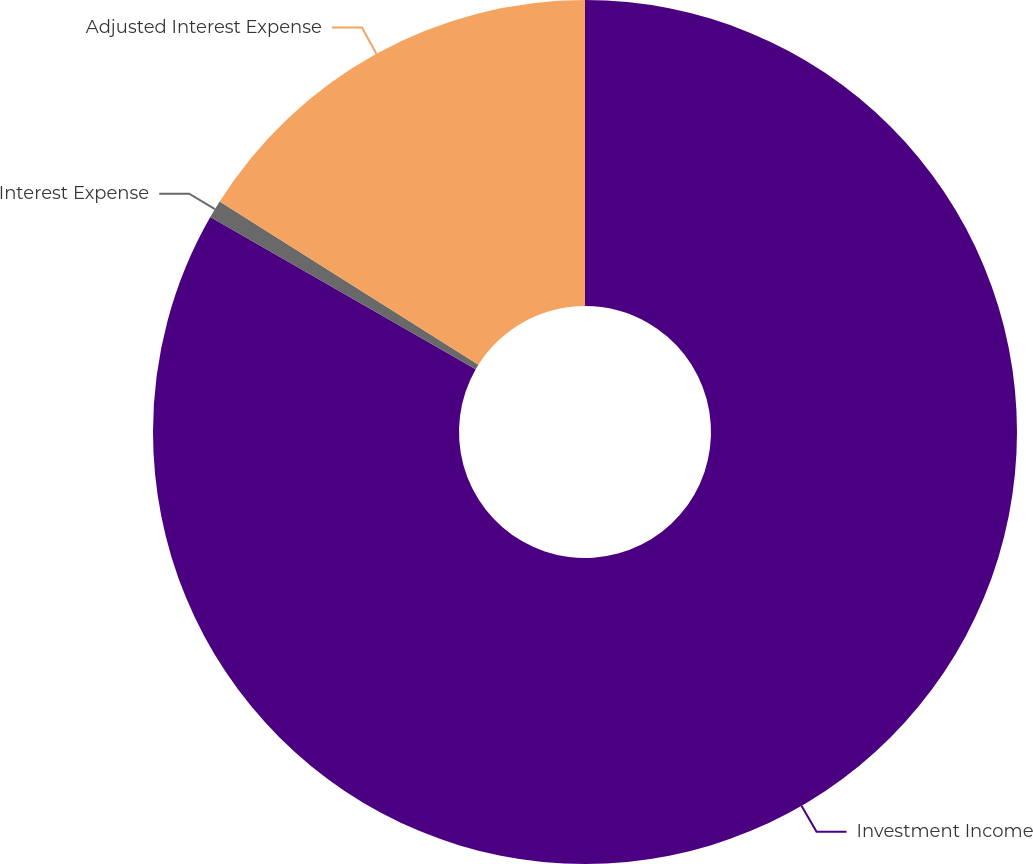<chart> <loc_0><loc_0><loc_500><loc_500><pie_chart><fcel>Investment Income<fcel>Interest Expense<fcel>Adjusted Interest Expense<nl><fcel>83.29%<fcel>0.67%<fcel>16.04%<nl></chart> 